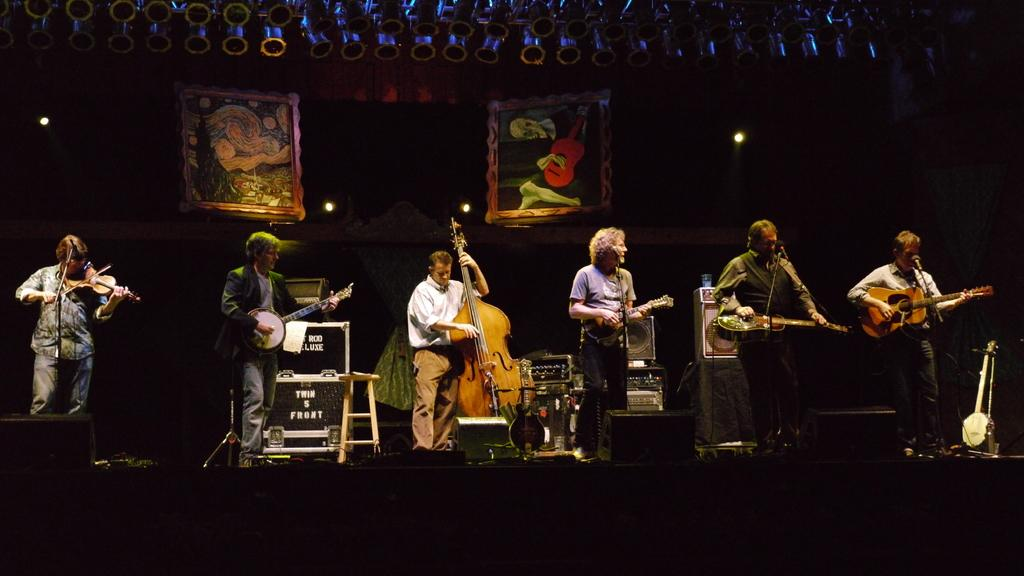How many people are performing in the image? There are six people in the image. What are they doing on the stage? They are playing a guitar and singing on a microphone. What type of rule is being enforced by the people in the image? There is no mention of a rule being enforced in the image; the people are performing on a stage, playing a guitar, and singing on a microphone. 